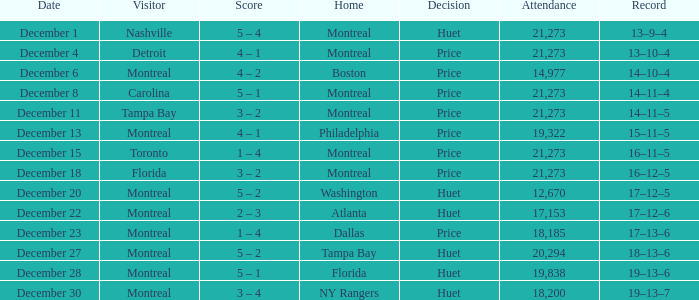What is the decision when the record is 13–10–4? Price. Parse the full table. {'header': ['Date', 'Visitor', 'Score', 'Home', 'Decision', 'Attendance', 'Record'], 'rows': [['December 1', 'Nashville', '5 – 4', 'Montreal', 'Huet', '21,273', '13–9–4'], ['December 4', 'Detroit', '4 – 1', 'Montreal', 'Price', '21,273', '13–10–4'], ['December 6', 'Montreal', '4 – 2', 'Boston', 'Price', '14,977', '14–10–4'], ['December 8', 'Carolina', '5 – 1', 'Montreal', 'Price', '21,273', '14–11–4'], ['December 11', 'Tampa Bay', '3 – 2', 'Montreal', 'Price', '21,273', '14–11–5'], ['December 13', 'Montreal', '4 – 1', 'Philadelphia', 'Price', '19,322', '15–11–5'], ['December 15', 'Toronto', '1 – 4', 'Montreal', 'Price', '21,273', '16–11–5'], ['December 18', 'Florida', '3 – 2', 'Montreal', 'Price', '21,273', '16–12–5'], ['December 20', 'Montreal', '5 – 2', 'Washington', 'Huet', '12,670', '17–12–5'], ['December 22', 'Montreal', '2 – 3', 'Atlanta', 'Huet', '17,153', '17–12–6'], ['December 23', 'Montreal', '1 – 4', 'Dallas', 'Price', '18,185', '17–13–6'], ['December 27', 'Montreal', '5 – 2', 'Tampa Bay', 'Huet', '20,294', '18–13–6'], ['December 28', 'Montreal', '5 – 1', 'Florida', 'Huet', '19,838', '19–13–6'], ['December 30', 'Montreal', '3 – 4', 'NY Rangers', 'Huet', '18,200', '19–13–7']]} 